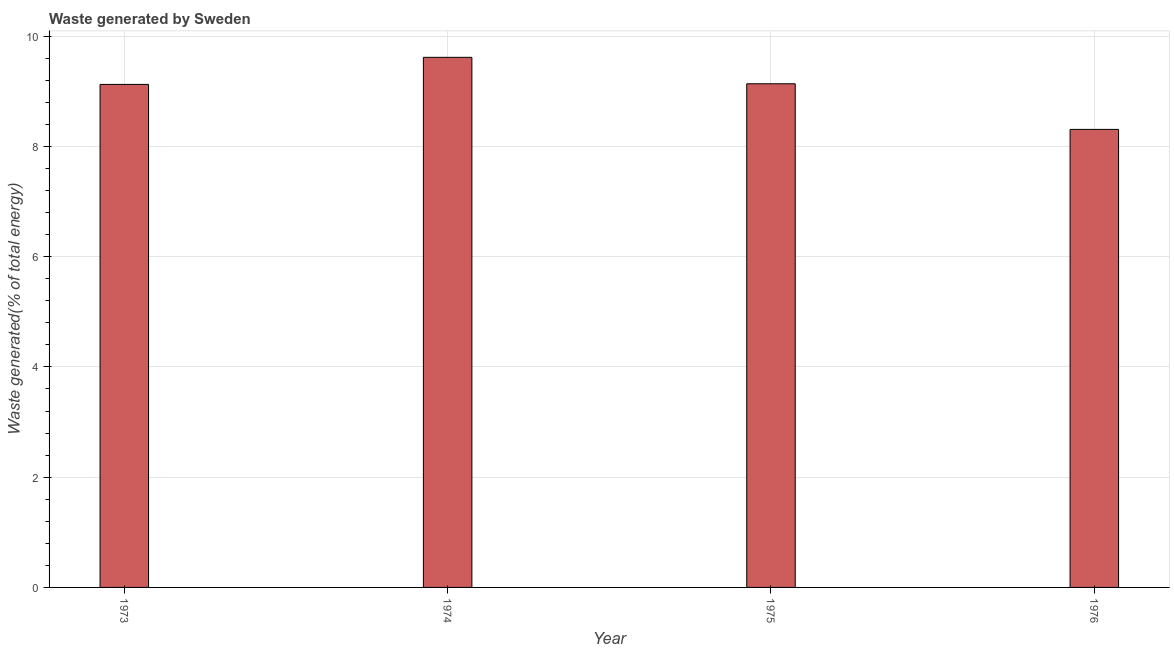Does the graph contain any zero values?
Offer a very short reply. No. What is the title of the graph?
Offer a very short reply. Waste generated by Sweden. What is the label or title of the Y-axis?
Your response must be concise. Waste generated(% of total energy). What is the amount of waste generated in 1975?
Provide a short and direct response. 9.14. Across all years, what is the maximum amount of waste generated?
Your answer should be compact. 9.62. Across all years, what is the minimum amount of waste generated?
Your answer should be very brief. 8.31. In which year was the amount of waste generated maximum?
Provide a short and direct response. 1974. In which year was the amount of waste generated minimum?
Give a very brief answer. 1976. What is the sum of the amount of waste generated?
Provide a succinct answer. 36.19. What is the difference between the amount of waste generated in 1973 and 1974?
Provide a short and direct response. -0.49. What is the average amount of waste generated per year?
Give a very brief answer. 9.05. What is the median amount of waste generated?
Keep it short and to the point. 9.13. In how many years, is the amount of waste generated greater than 6.4 %?
Make the answer very short. 4. Do a majority of the years between 1975 and 1973 (inclusive) have amount of waste generated greater than 0.4 %?
Provide a short and direct response. Yes. What is the ratio of the amount of waste generated in 1973 to that in 1974?
Provide a succinct answer. 0.95. Is the amount of waste generated in 1975 less than that in 1976?
Provide a succinct answer. No. Is the difference between the amount of waste generated in 1973 and 1976 greater than the difference between any two years?
Keep it short and to the point. No. What is the difference between the highest and the second highest amount of waste generated?
Ensure brevity in your answer.  0.48. Is the sum of the amount of waste generated in 1973 and 1976 greater than the maximum amount of waste generated across all years?
Keep it short and to the point. Yes. What is the difference between the highest and the lowest amount of waste generated?
Give a very brief answer. 1.31. Are all the bars in the graph horizontal?
Offer a terse response. No. What is the Waste generated(% of total energy) of 1973?
Provide a short and direct response. 9.13. What is the Waste generated(% of total energy) of 1974?
Your answer should be compact. 9.62. What is the Waste generated(% of total energy) of 1975?
Your response must be concise. 9.14. What is the Waste generated(% of total energy) of 1976?
Offer a very short reply. 8.31. What is the difference between the Waste generated(% of total energy) in 1973 and 1974?
Your answer should be very brief. -0.49. What is the difference between the Waste generated(% of total energy) in 1973 and 1975?
Your answer should be compact. -0.01. What is the difference between the Waste generated(% of total energy) in 1973 and 1976?
Ensure brevity in your answer.  0.82. What is the difference between the Waste generated(% of total energy) in 1974 and 1975?
Make the answer very short. 0.48. What is the difference between the Waste generated(% of total energy) in 1974 and 1976?
Your answer should be compact. 1.31. What is the difference between the Waste generated(% of total energy) in 1975 and 1976?
Provide a short and direct response. 0.83. What is the ratio of the Waste generated(% of total energy) in 1973 to that in 1974?
Your response must be concise. 0.95. What is the ratio of the Waste generated(% of total energy) in 1973 to that in 1975?
Keep it short and to the point. 1. What is the ratio of the Waste generated(% of total energy) in 1973 to that in 1976?
Your answer should be compact. 1.1. What is the ratio of the Waste generated(% of total energy) in 1974 to that in 1975?
Make the answer very short. 1.05. What is the ratio of the Waste generated(% of total energy) in 1974 to that in 1976?
Ensure brevity in your answer.  1.16. What is the ratio of the Waste generated(% of total energy) in 1975 to that in 1976?
Ensure brevity in your answer.  1.1. 